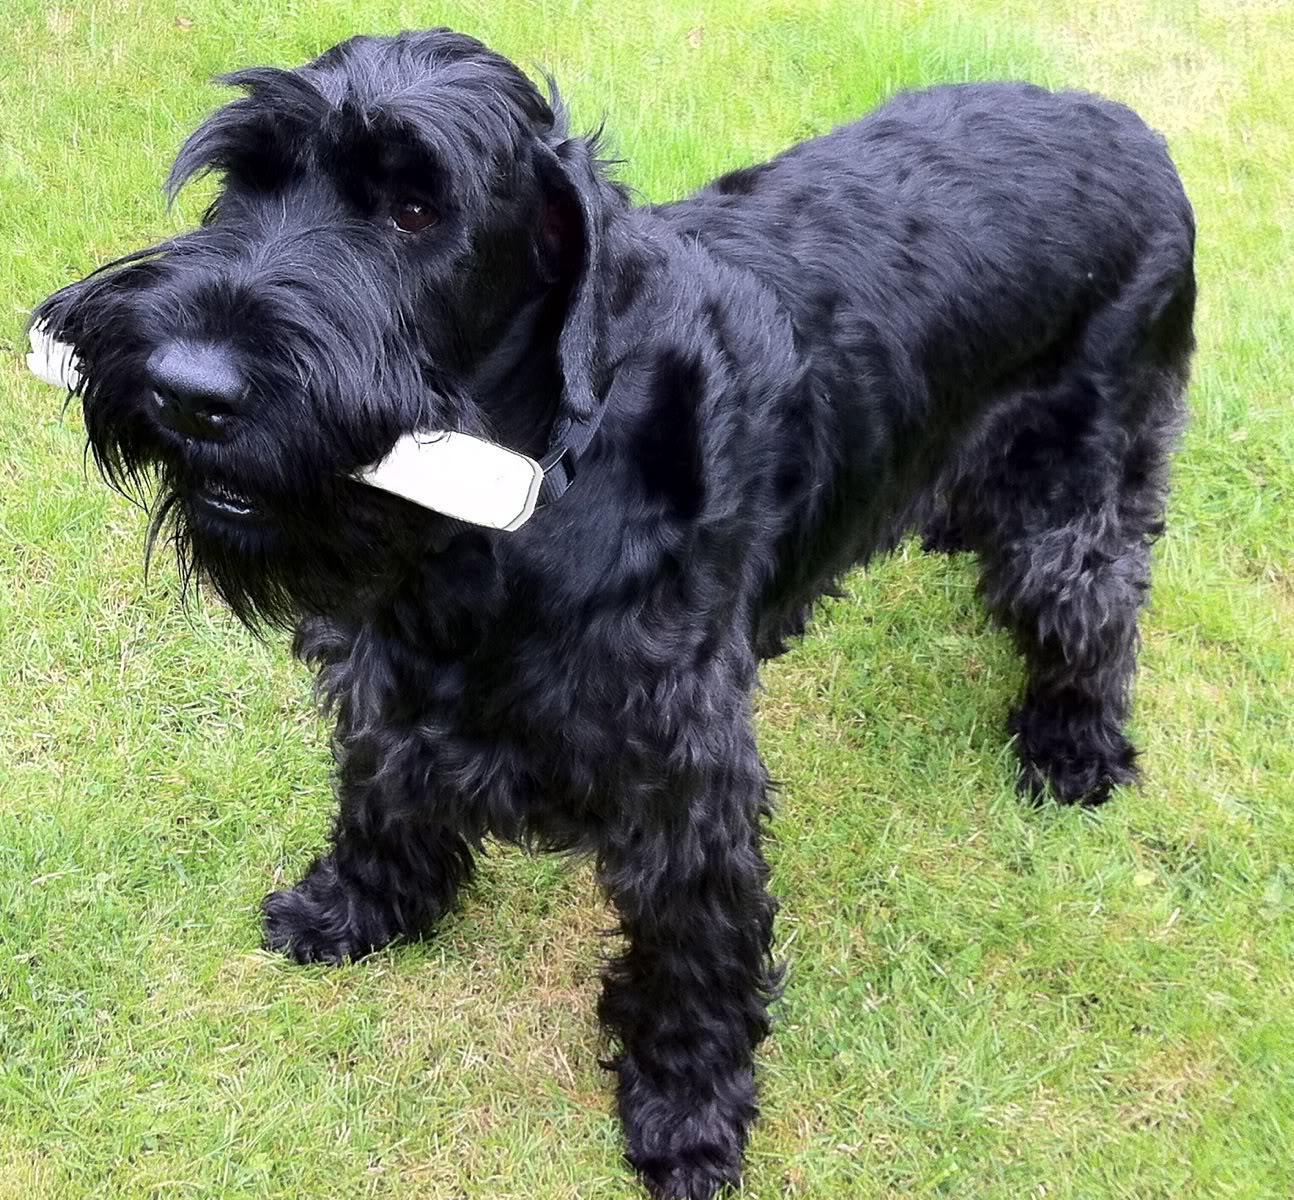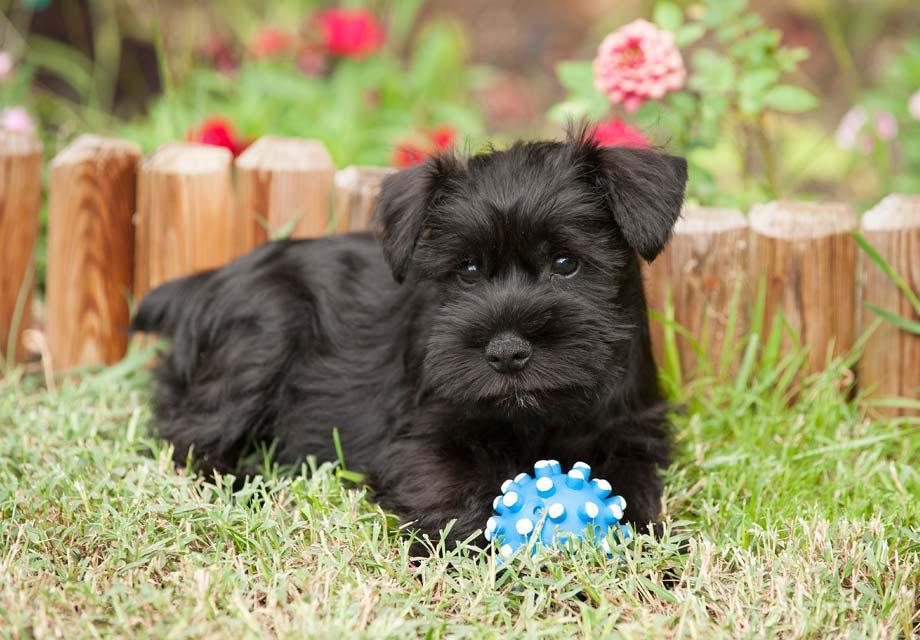The first image is the image on the left, the second image is the image on the right. Evaluate the accuracy of this statement regarding the images: "In 1 of the images, 1 dog has an object in its mouth.". Is it true? Answer yes or no. Yes. The first image is the image on the left, the second image is the image on the right. Assess this claim about the two images: "All images show dogs outdoors with grass.". Correct or not? Answer yes or no. Yes. 